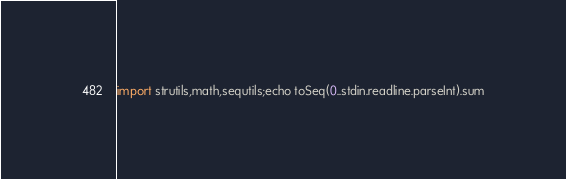Convert code to text. <code><loc_0><loc_0><loc_500><loc_500><_Nim_>import strutils,math,sequtils;echo toSeq(0..stdin.readline.parseInt).sum</code> 